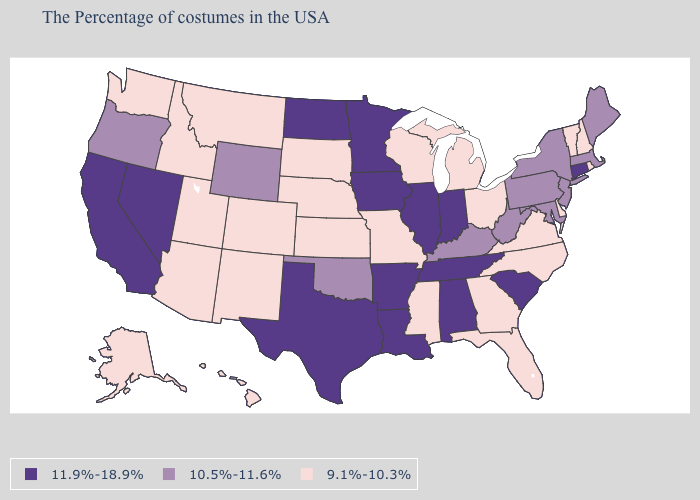Does Alaska have the highest value in the USA?
Quick response, please. No. What is the lowest value in states that border North Carolina?
Be succinct. 9.1%-10.3%. Does Maryland have a lower value than Connecticut?
Write a very short answer. Yes. Name the states that have a value in the range 11.9%-18.9%?
Give a very brief answer. Connecticut, South Carolina, Indiana, Alabama, Tennessee, Illinois, Louisiana, Arkansas, Minnesota, Iowa, Texas, North Dakota, Nevada, California. What is the lowest value in the MidWest?
Quick response, please. 9.1%-10.3%. What is the value of New York?
Quick response, please. 10.5%-11.6%. Name the states that have a value in the range 9.1%-10.3%?
Short answer required. Rhode Island, New Hampshire, Vermont, Delaware, Virginia, North Carolina, Ohio, Florida, Georgia, Michigan, Wisconsin, Mississippi, Missouri, Kansas, Nebraska, South Dakota, Colorado, New Mexico, Utah, Montana, Arizona, Idaho, Washington, Alaska, Hawaii. What is the value of Connecticut?
Short answer required. 11.9%-18.9%. What is the lowest value in the West?
Keep it brief. 9.1%-10.3%. What is the highest value in states that border Virginia?
Concise answer only. 11.9%-18.9%. Does the map have missing data?
Be succinct. No. What is the highest value in the USA?
Concise answer only. 11.9%-18.9%. Is the legend a continuous bar?
Short answer required. No. What is the value of North Carolina?
Give a very brief answer. 9.1%-10.3%. Name the states that have a value in the range 10.5%-11.6%?
Concise answer only. Maine, Massachusetts, New York, New Jersey, Maryland, Pennsylvania, West Virginia, Kentucky, Oklahoma, Wyoming, Oregon. 